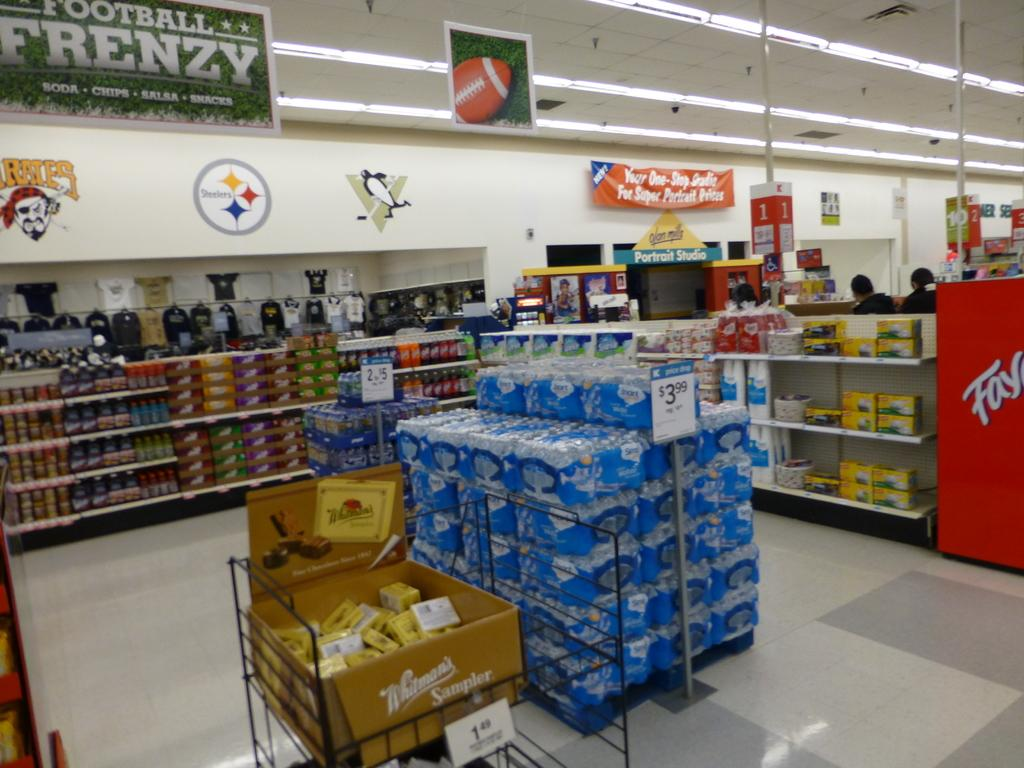<image>
Give a short and clear explanation of the subsequent image. A display of store brand water next to some Whitmans chocolates 